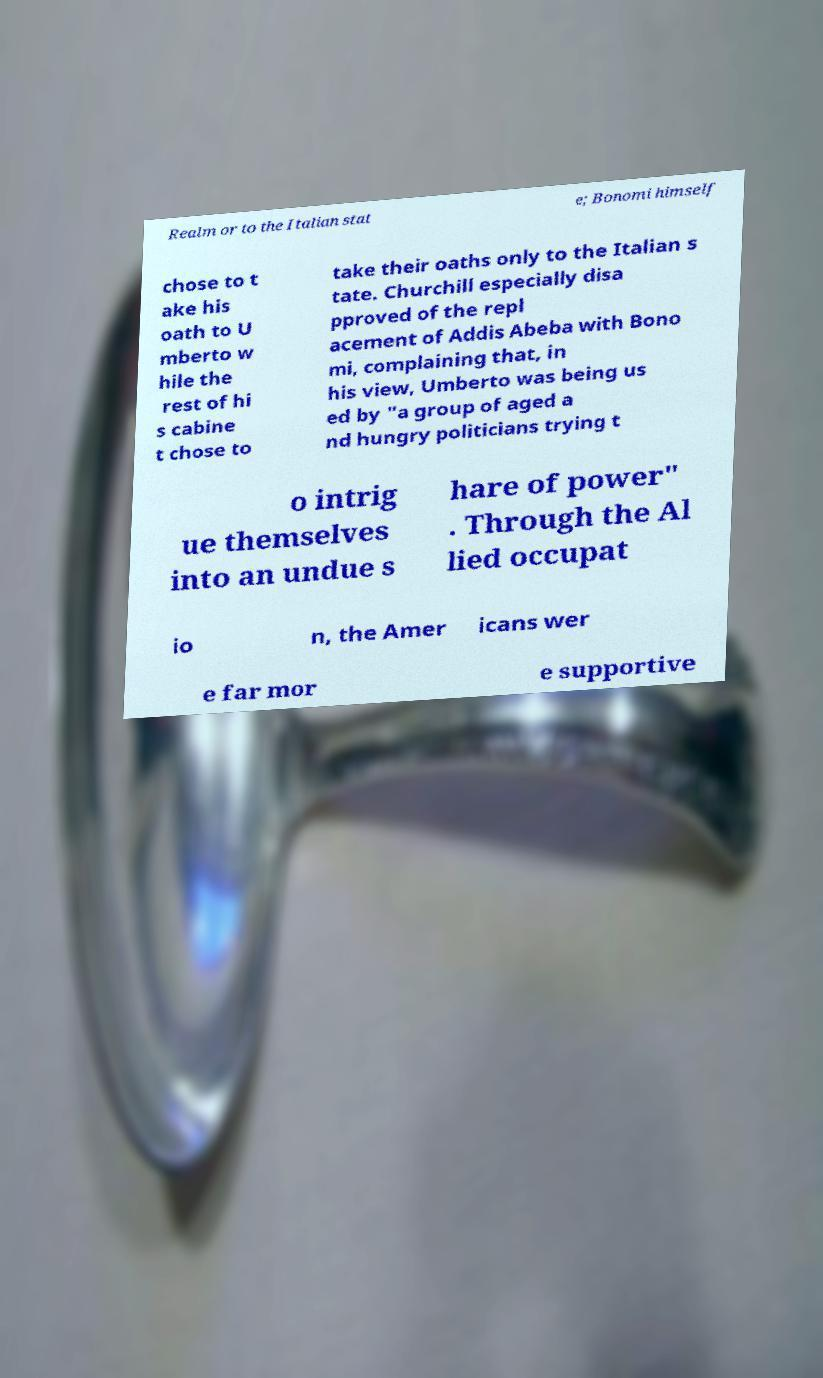Could you assist in decoding the text presented in this image and type it out clearly? Realm or to the Italian stat e; Bonomi himself chose to t ake his oath to U mberto w hile the rest of hi s cabine t chose to take their oaths only to the Italian s tate. Churchill especially disa pproved of the repl acement of Addis Abeba with Bono mi, complaining that, in his view, Umberto was being us ed by "a group of aged a nd hungry politicians trying t o intrig ue themselves into an undue s hare of power" . Through the Al lied occupat io n, the Amer icans wer e far mor e supportive 